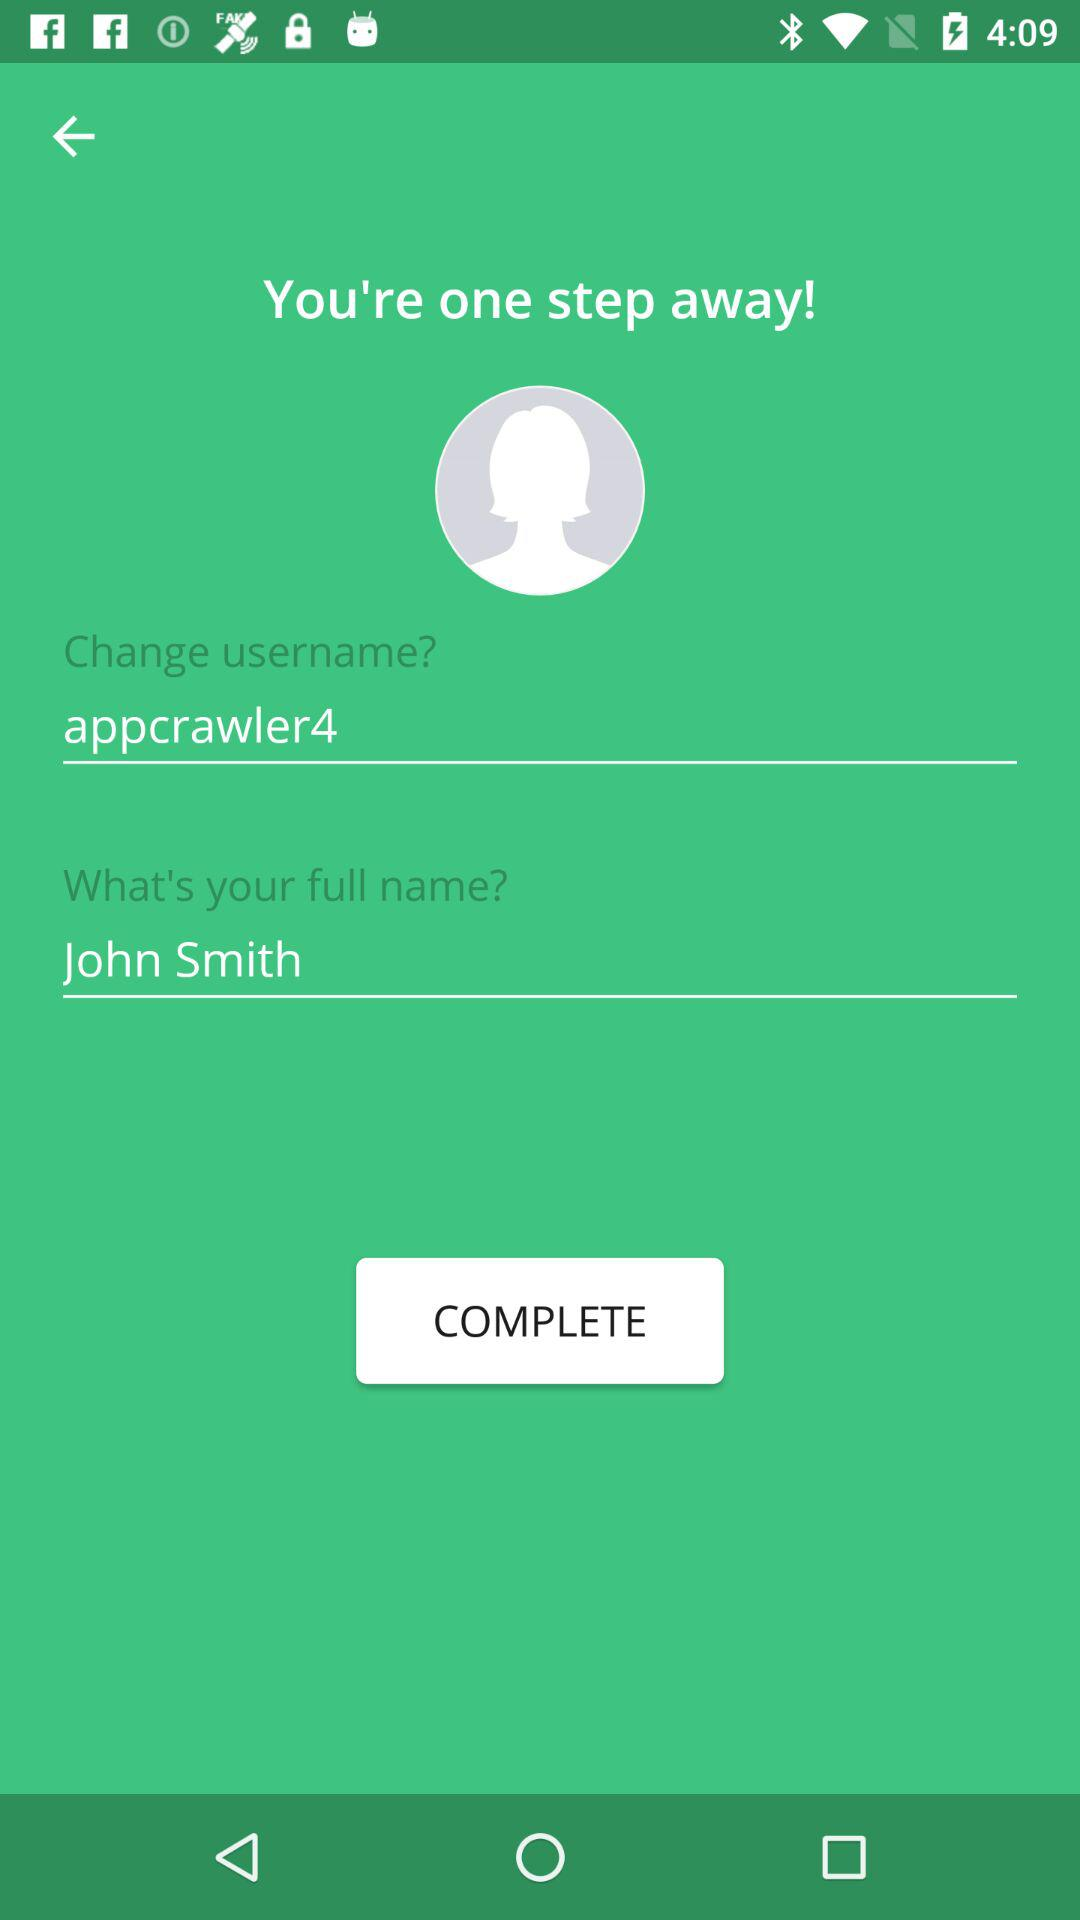What is the username? The username is "appcrawler4". 